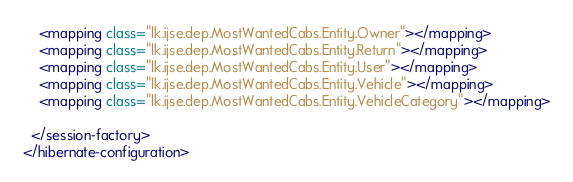<code> <loc_0><loc_0><loc_500><loc_500><_XML_>    <mapping class="lk.ijse.dep.MostWantedCabs.Entity.Owner"></mapping>
    <mapping class="lk.ijse.dep.MostWantedCabs.Entity.Return"></mapping>
    <mapping class="lk.ijse.dep.MostWantedCabs.Entity.User"></mapping>
    <mapping class="lk.ijse.dep.MostWantedCabs.Entity.Vehicle"></mapping>
    <mapping class="lk.ijse.dep.MostWantedCabs.Entity.VehicleCategory"></mapping>

  </session-factory>
</hibernate-configuration></code> 